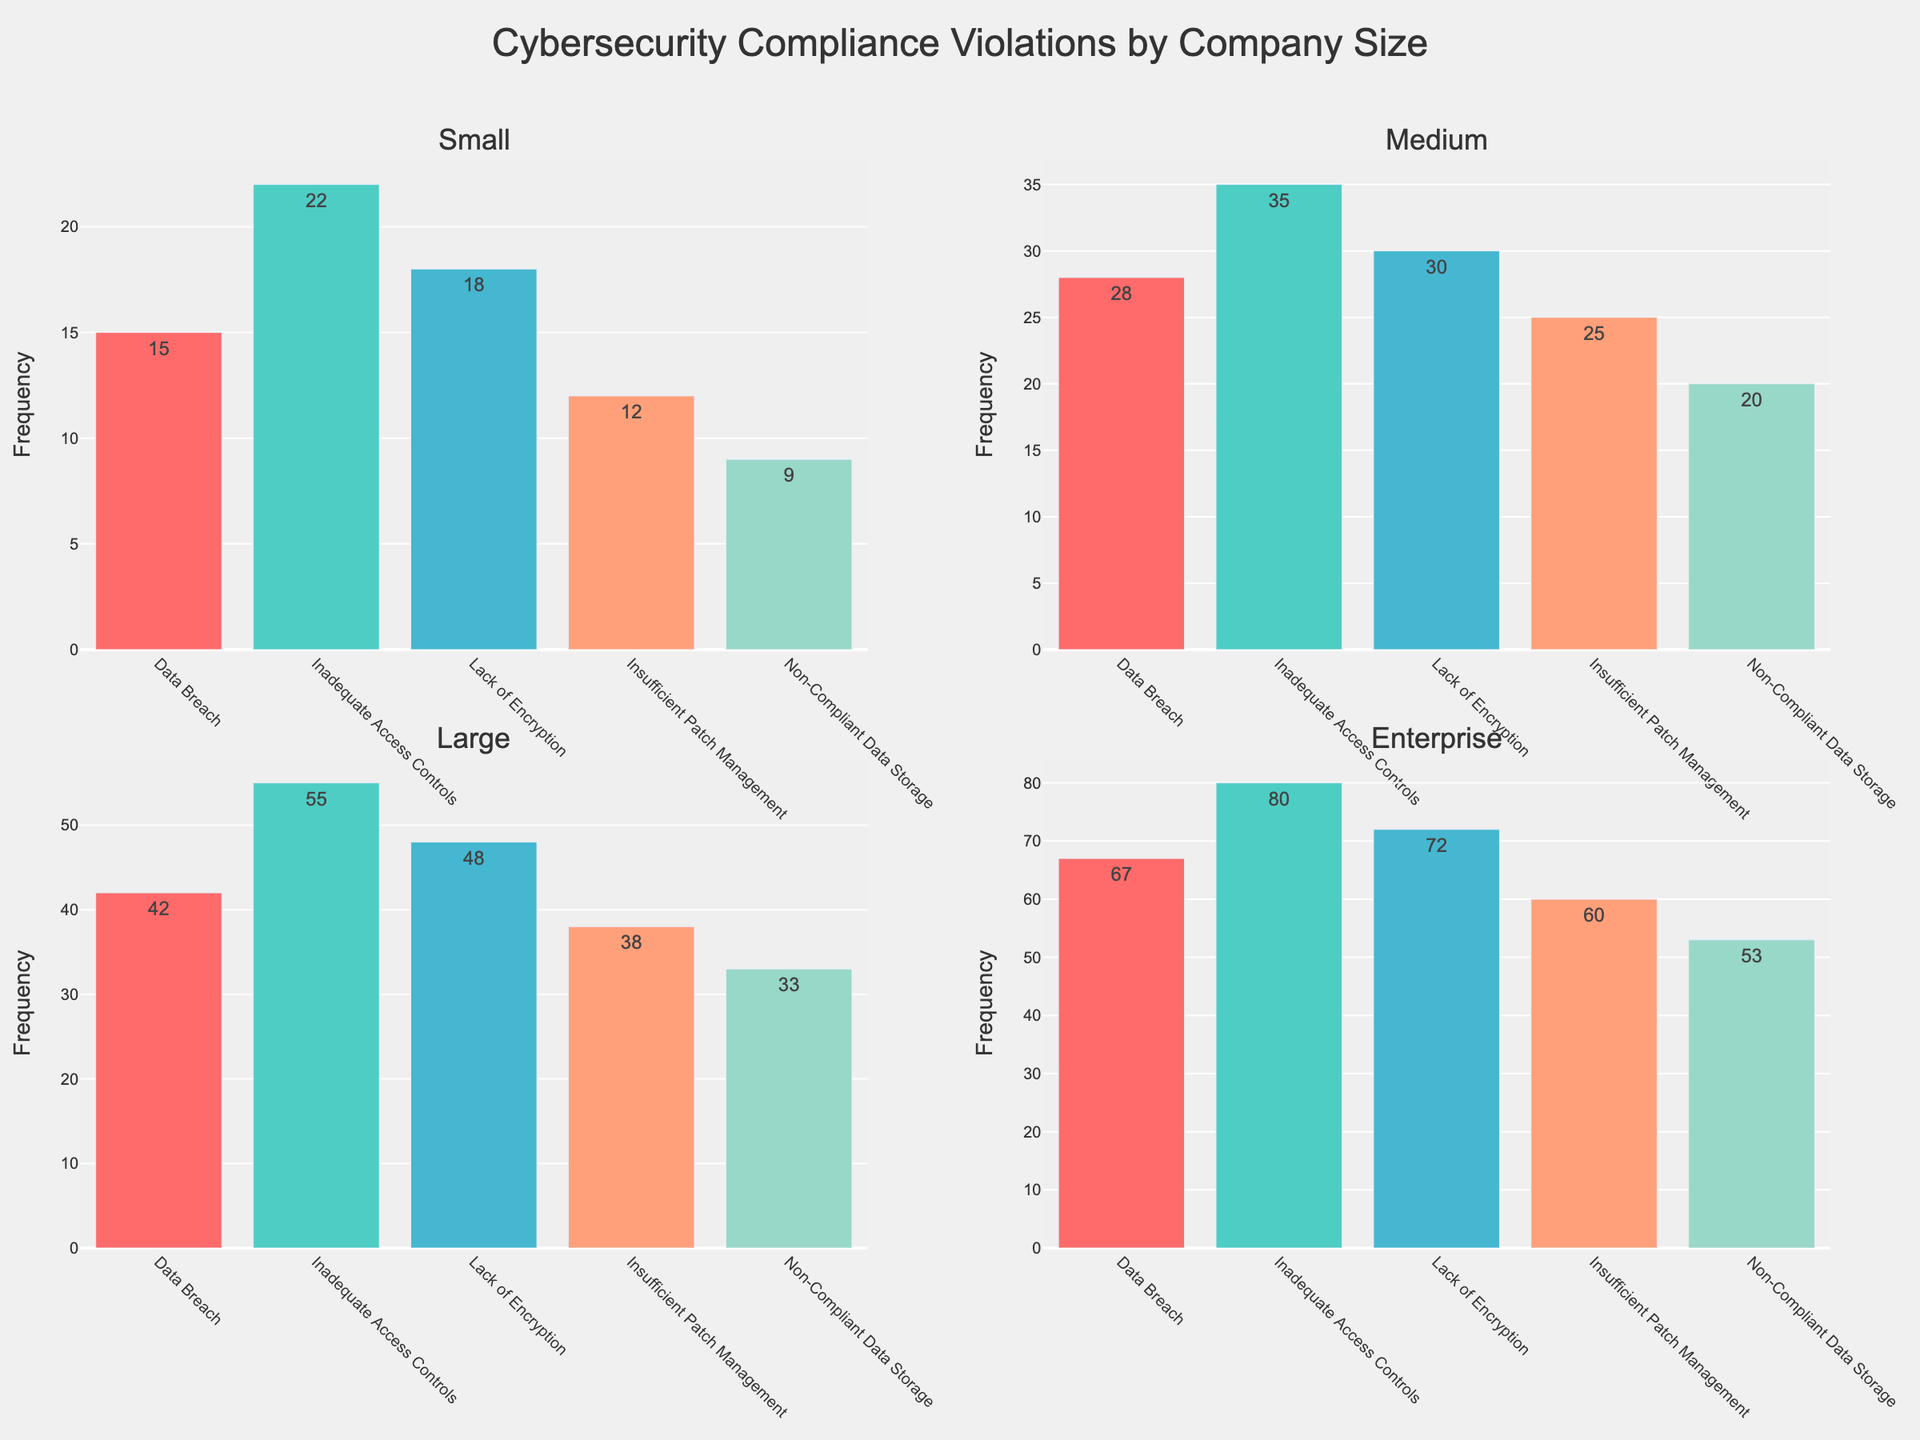What is the title of the figure? The title of the figure is prominently displayed at the top and reads "Cybersecurity Compliance Violations by Company Size".
Answer: Cybersecurity Compliance Violations by Company Size Which company size has the highest frequency of "Lack of Encryption" violations? By looking at each subplot's y-axis where "Lack of Encryption" is plotted, we can see that the "Enterprise" subplot has the highest bar for this violation type, with a frequency of 72.
Answer: Enterprise How many total violations of "Data Breach" are there across all company sizes? The frequencies for "Data Breach" in each subplot are 15 (Small), 28 (Medium), 42 (Large), and 67 (Enterprise). Adding these gives 15 + 28 + 42 + 67 = 152.
Answer: 152 What is the difference in frequency of "Insufficient Patch Management" violations between the smallest and largest company sizes? From the subplots, the smallest (Small) company's "Insufficient Patch Management" frequency is 12, and the largest (Enterprise) is 60. The difference is 60 - 12 = 48.
Answer: 48 Which violation type is the least frequent among Medium-sized companies? Looking at the bars within the "Medium" subplot, "Non-Compliant Data Storage" is the shortest, with a frequency of 20.
Answer: Non-Compliant Data Storage In which company size do "Inadequate Access Controls" violations appear most frequently, and what is the frequency? Examining each subplot, "Inadequate Access Controls" appears most frequently in the "Enterprise" subplot with a frequency of 80.
Answer: Enterprise, 80 Compare the frequency of "Non-Compliant Data Storage" violations across Small and Large company sizes. Which has more, and by how much? The frequency of "Non-Compliant Data Storage" violations is 9 for Small companies and 33 for Large companies. Large companies have more by 33 - 9 = 24.
Answer: Large, 24 What is the average frequency of "Lack of Encryption" violations across all company sizes? The frequencies are 18 (Small), 30 (Medium), 48 (Large), and 72 (Enterprise), summing to 18 + 30 + 48 + 72 = 168. The average is 168 / 4 = 42.
Answer: 42 